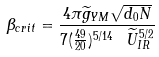<formula> <loc_0><loc_0><loc_500><loc_500>\beta _ { c r i t } = \frac { 4 \pi \widetilde { g } _ { Y M } \sqrt { d _ { 0 } N } } { 7 ( \frac { 4 9 } { 2 0 } ) ^ { 5 / 1 4 } \ \widetilde { U } _ { I R } ^ { 5 / 2 } }</formula> 